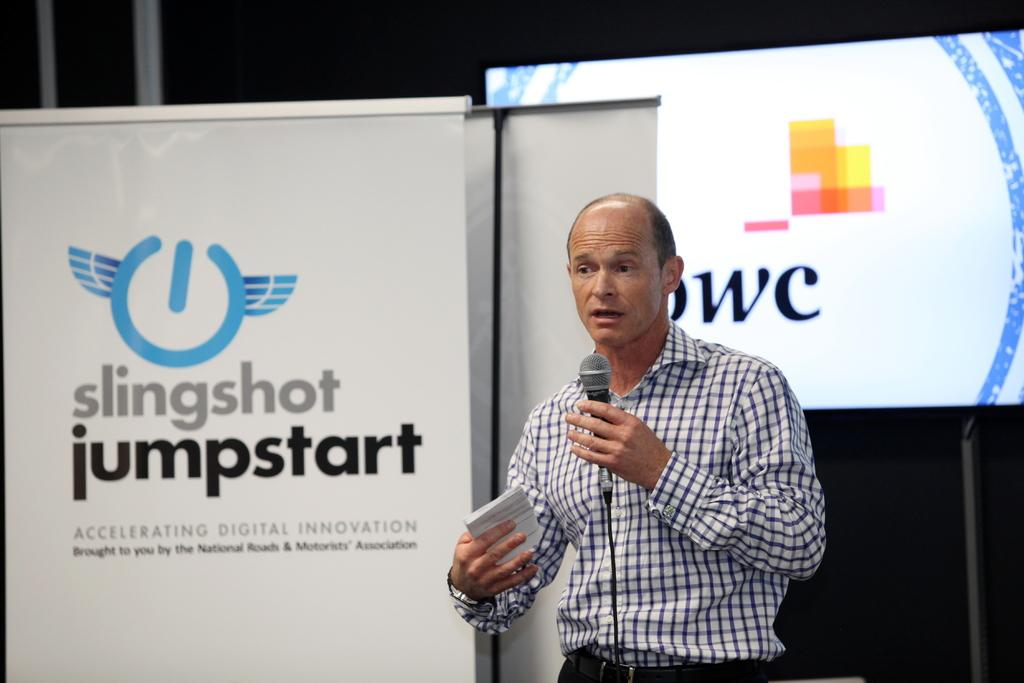What is the person in the center of the image doing? The person is standing in the center of the image and holding a mic. What else is the person holding in the image? The person is also holding a paper. What can be seen in the background of the image? There is a screen in the background of the image. What is displayed on the screen? There is an advertisement on the screen. What type of ornament is hanging from the person's neck in the image? There is no ornament hanging from the person's neck in the image. What kind of flowers can be seen on the table in the image? There is no table or flowers present in the image. 